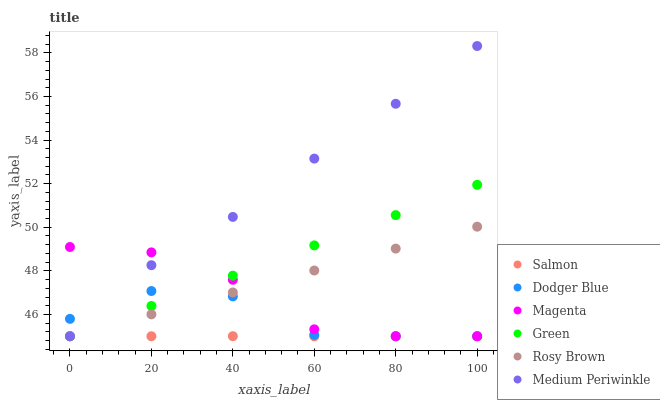Does Salmon have the minimum area under the curve?
Answer yes or no. Yes. Does Medium Periwinkle have the maximum area under the curve?
Answer yes or no. Yes. Does Rosy Brown have the minimum area under the curve?
Answer yes or no. No. Does Rosy Brown have the maximum area under the curve?
Answer yes or no. No. Is Rosy Brown the smoothest?
Answer yes or no. Yes. Is Dodger Blue the roughest?
Answer yes or no. Yes. Is Salmon the smoothest?
Answer yes or no. No. Is Salmon the roughest?
Answer yes or no. No. Does Medium Periwinkle have the lowest value?
Answer yes or no. Yes. Does Medium Periwinkle have the highest value?
Answer yes or no. Yes. Does Rosy Brown have the highest value?
Answer yes or no. No. Does Green intersect Dodger Blue?
Answer yes or no. Yes. Is Green less than Dodger Blue?
Answer yes or no. No. Is Green greater than Dodger Blue?
Answer yes or no. No. 